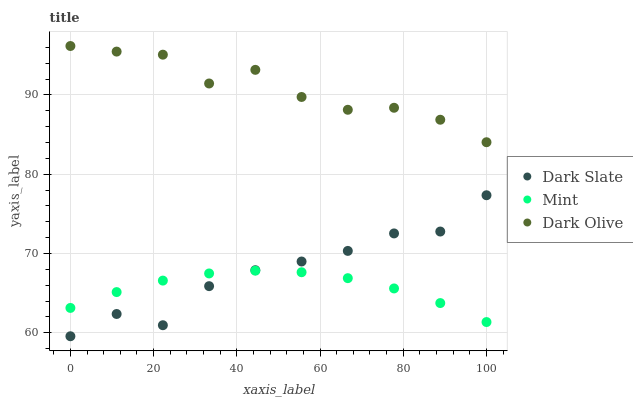Does Mint have the minimum area under the curve?
Answer yes or no. Yes. Does Dark Olive have the maximum area under the curve?
Answer yes or no. Yes. Does Dark Olive have the minimum area under the curve?
Answer yes or no. No. Does Mint have the maximum area under the curve?
Answer yes or no. No. Is Mint the smoothest?
Answer yes or no. Yes. Is Dark Slate the roughest?
Answer yes or no. Yes. Is Dark Olive the smoothest?
Answer yes or no. No. Is Dark Olive the roughest?
Answer yes or no. No. Does Dark Slate have the lowest value?
Answer yes or no. Yes. Does Mint have the lowest value?
Answer yes or no. No. Does Dark Olive have the highest value?
Answer yes or no. Yes. Does Mint have the highest value?
Answer yes or no. No. Is Mint less than Dark Olive?
Answer yes or no. Yes. Is Dark Olive greater than Mint?
Answer yes or no. Yes. Does Mint intersect Dark Slate?
Answer yes or no. Yes. Is Mint less than Dark Slate?
Answer yes or no. No. Is Mint greater than Dark Slate?
Answer yes or no. No. Does Mint intersect Dark Olive?
Answer yes or no. No. 